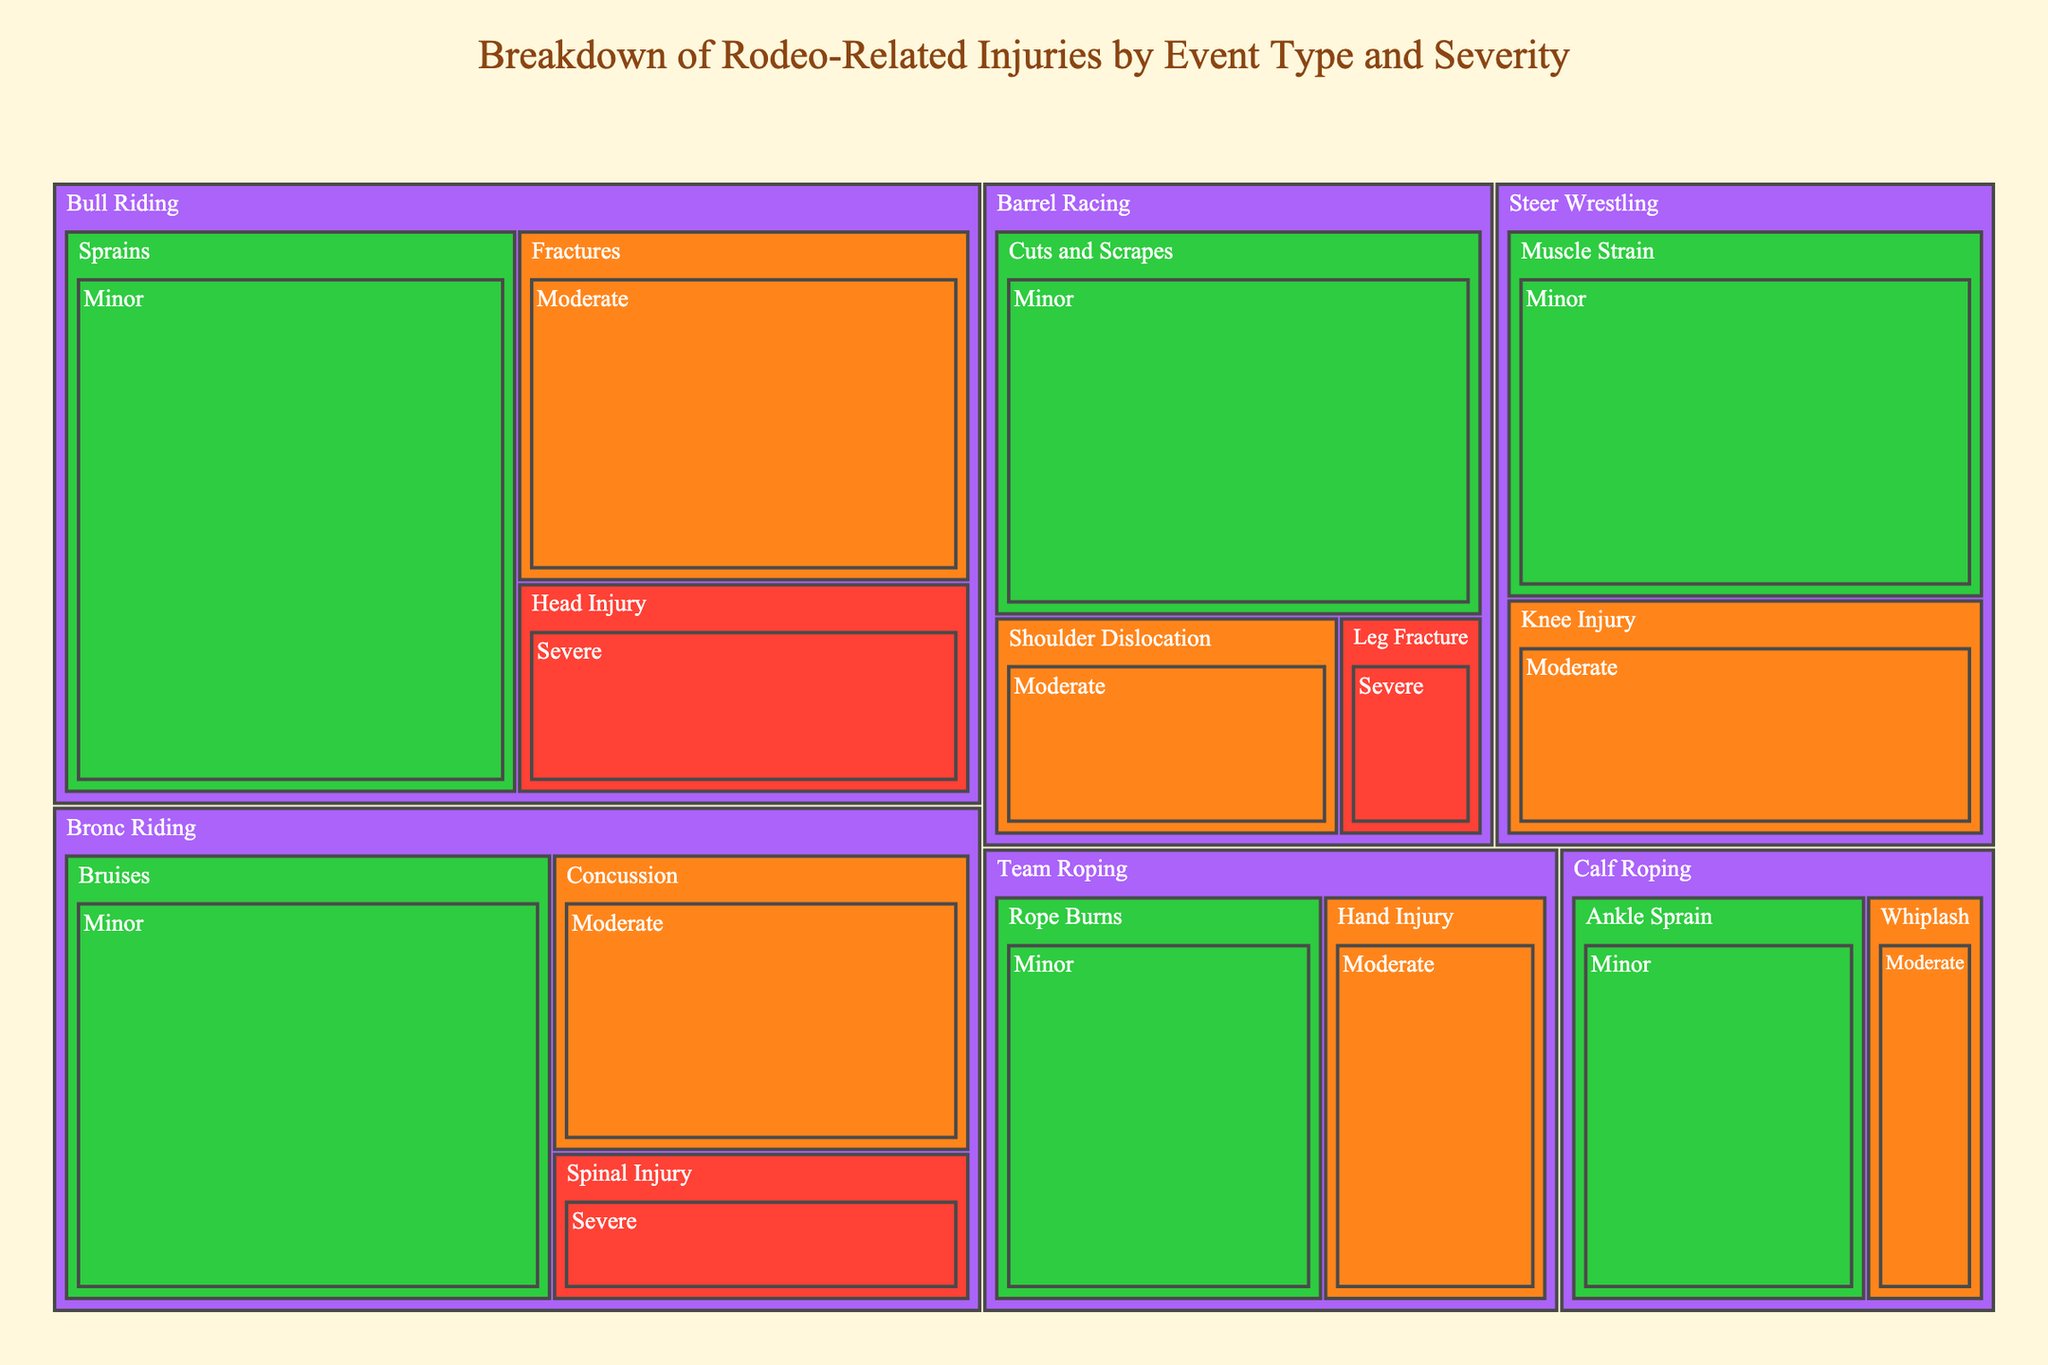What's the title of the figure? The title is displayed at the top of the treemap and summarizes what the figure is about. The title states: "Breakdown of Rodeo-Related Injuries by Event Type and Severity".
Answer: Breakdown of Rodeo-Related Injuries by Event Type and Severity Which event has the highest number of severe injuries? To identify which event has the highest number of severe injuries, look at the "Severe" category within each event. Bull Riding has the highest count with 15 severe injuries.
Answer: Bull Riding What are the total number of injuries in Bronc Riding? Sum up all the injuries in Bronc Riding across all severity levels: Severe (10), Moderate (20), and Minor (35). Therefore, 10 + 20 + 35 = 65.
Answer: 65 Compare the number of moderate injuries between Bull Riding and Steer Wrestling. Which one has more? Look at the count of moderate injuries for both Bull Riding (25) and Steer Wrestling (18). Bull Riding has more moderate injuries than Steer Wrestling.
Answer: Bull Riding What is the color used to represent minor injuries in the treemap? The color representing minor injuries is visible on the treemap. Minor injuries are shown in green.
Answer: Green Which event has the least number of severe injuries? The event with the least number of severe injuries is Barrel Racing, which has 5 severe injuries.
Answer: Barrel Racing How many total injuries are there in Barrel Racing, considering all severities? Sum up all the injuries in Barrel Racing across all severity levels: Severe (5), Moderate (12), and Minor (30). Therefore, 5 + 12 + 30 = 47.
Answer: 47 What is the combined total of moderate injuries for Bull Riding and Team Roping? Add the moderate injuries for Bull Riding (25) and Team Roping (15). Therefore, 25 + 15 = 40.
Answer: 40 Which type of injury has the highest count in Team Roping? Review the counts of each type of injury in Team Roping. The highest count is for "Rope Burns" with 22 minor injuries.
Answer: Rope Burns How many more minor injuries are there in Bronc Riding compared to Calf Roping? Subtract the number of minor injuries in Calf Roping (20) from the number of minor injuries in Bronc Riding (35). Therefore, 35 - 20 = 15.
Answer: 15 